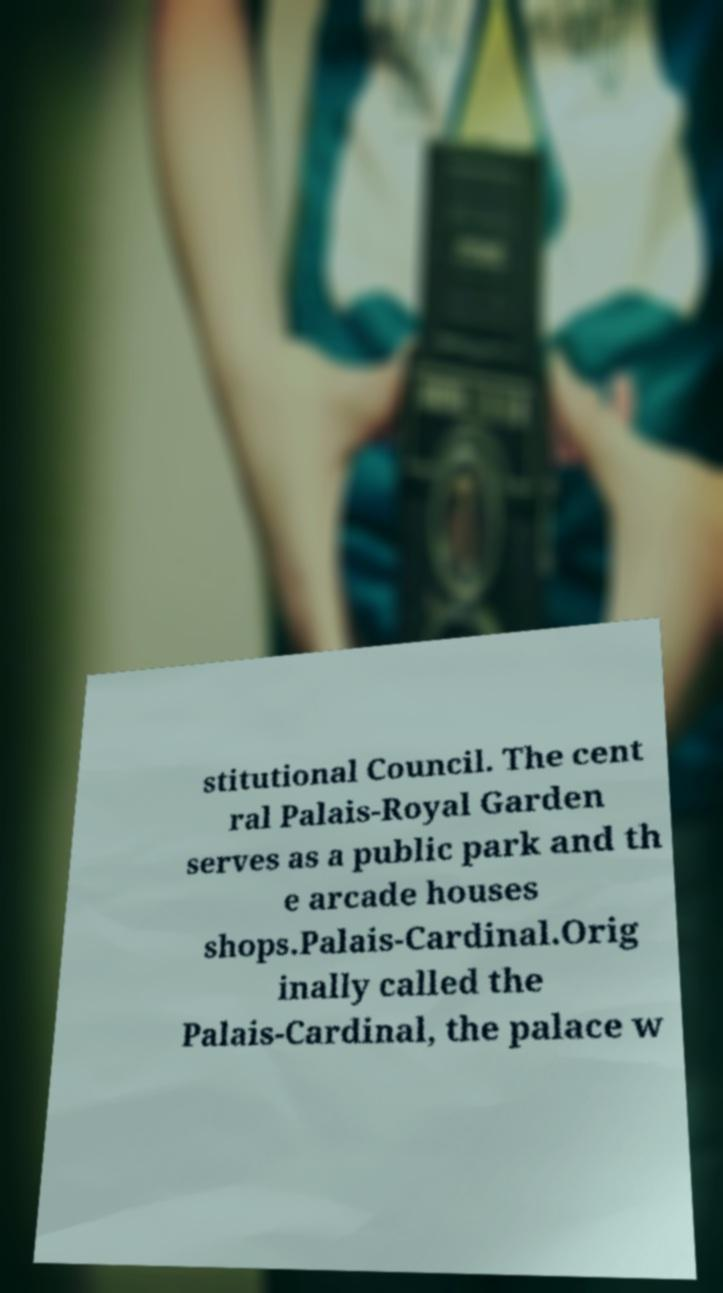Can you accurately transcribe the text from the provided image for me? stitutional Council. The cent ral Palais-Royal Garden serves as a public park and th e arcade houses shops.Palais-Cardinal.Orig inally called the Palais-Cardinal, the palace w 